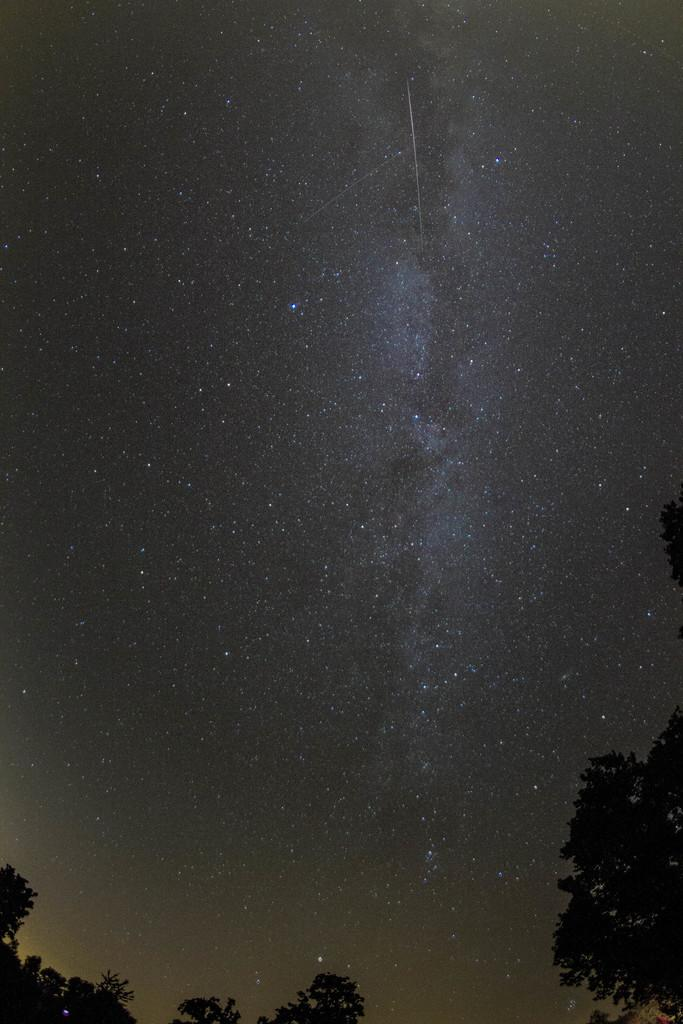What time of day is depicted in the image? The image depicts a night view. What can be seen at the bottom of the image? There are trees in the front bottom side of the image. What is visible in the top part of the image? There are many stars visible in the sky in the top part of the image. What type of soap is being used to clean the gold in the image? There is no soap or gold present in the image; it depicts a night view with trees and stars. 